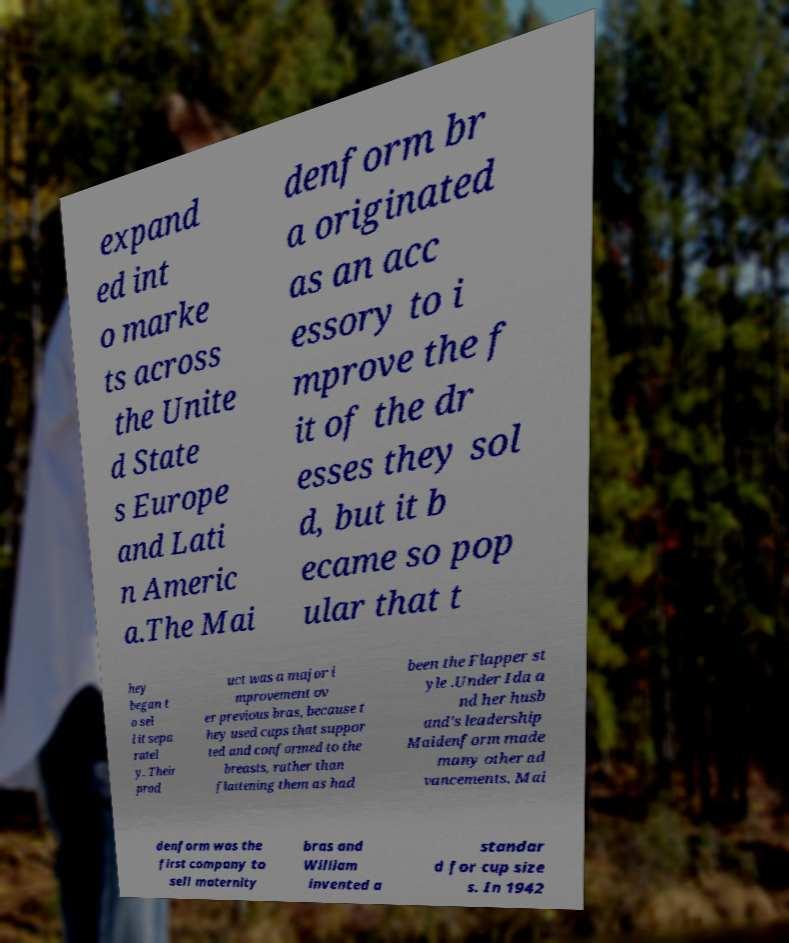What messages or text are displayed in this image? I need them in a readable, typed format. expand ed int o marke ts across the Unite d State s Europe and Lati n Americ a.The Mai denform br a originated as an acc essory to i mprove the f it of the dr esses they sol d, but it b ecame so pop ular that t hey began t o sel l it sepa ratel y. Their prod uct was a major i mprovement ov er previous bras, because t hey used cups that suppor ted and conformed to the breasts, rather than flattening them as had been the Flapper st yle .Under Ida a nd her husb and's leadership Maidenform made many other ad vancements. Mai denform was the first company to sell maternity bras and William invented a standar d for cup size s. In 1942 